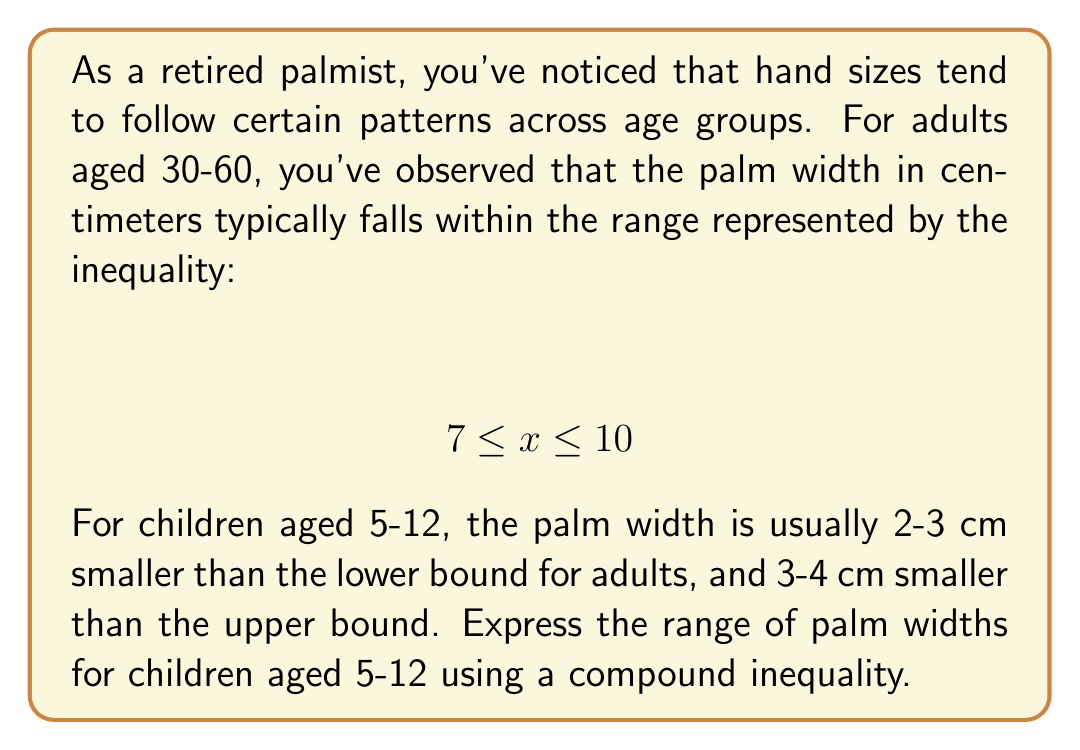Show me your answer to this math problem. Let's approach this step-by-step:

1) We start with the adult range: $7 \leq x \leq 10$

2) For children, the lower bound is 2-3 cm smaller than the adult lower bound:
   Lower bound for children = $7 - 3 \leq x \leq 7 - 2$
   $4 \leq x \leq 5$

3) The upper bound for children is 3-4 cm smaller than the adult upper bound:
   Upper bound for children = $10 - 4 \leq x \leq 10 - 3$
   $6 \leq x \leq 7$

4) Combining these, we get:
   $4 \leq x \leq 5$ for the lower bound
   $6 \leq x \leq 7$ for the upper bound

5) To express this as a single compound inequality, we take the larger of the lower bounds (4) and the smaller of the upper bounds (7):

   $4 \leq x \leq 7$

This inequality represents the full range of possible palm widths for children aged 5-12, according to the given information.
Answer: $4 \leq x \leq 7$ 